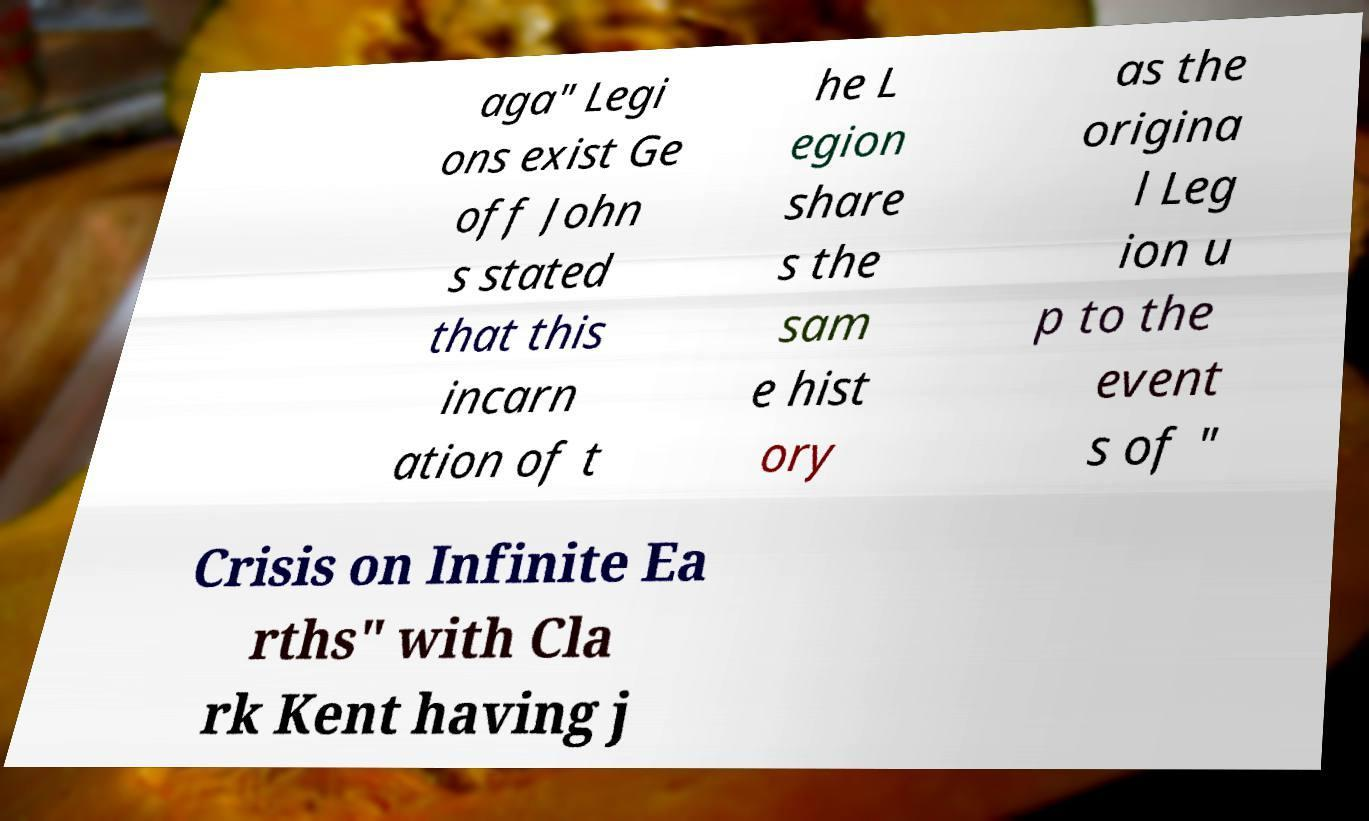Please read and relay the text visible in this image. What does it say? aga" Legi ons exist Ge off John s stated that this incarn ation of t he L egion share s the sam e hist ory as the origina l Leg ion u p to the event s of " Crisis on Infinite Ea rths" with Cla rk Kent having j 